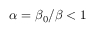Convert formula to latex. <formula><loc_0><loc_0><loc_500><loc_500>\alpha = \beta _ { 0 } / \beta < 1</formula> 